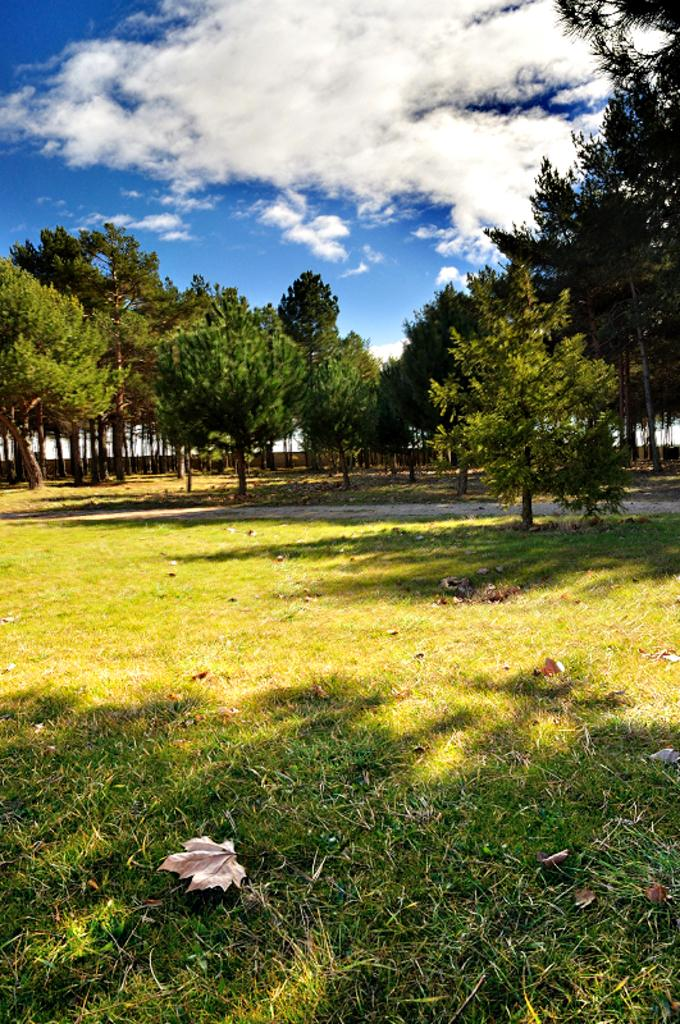What type of vegetation is in the middle of the image? There are trees in the middle of the image. What type of ground cover is at the bottom of the image? There is grass at the bottom of the image. What is present on the grass in the image? Dry leaves are present on the grass. What is visible at the top of the image? The sky is visible at the top of the image. What can be seen in the sky in the image? Clouds are present in the sky. Can you tell me how many people are flying a kite in the image? There is no kite present in the image, so it is not possible to determine how many people might be flying one. 